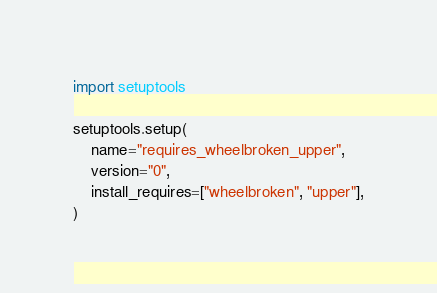<code> <loc_0><loc_0><loc_500><loc_500><_Python_>import setuptools

setuptools.setup(
    name="requires_wheelbroken_upper",
    version="0",
    install_requires=["wheelbroken", "upper"],
)
</code> 